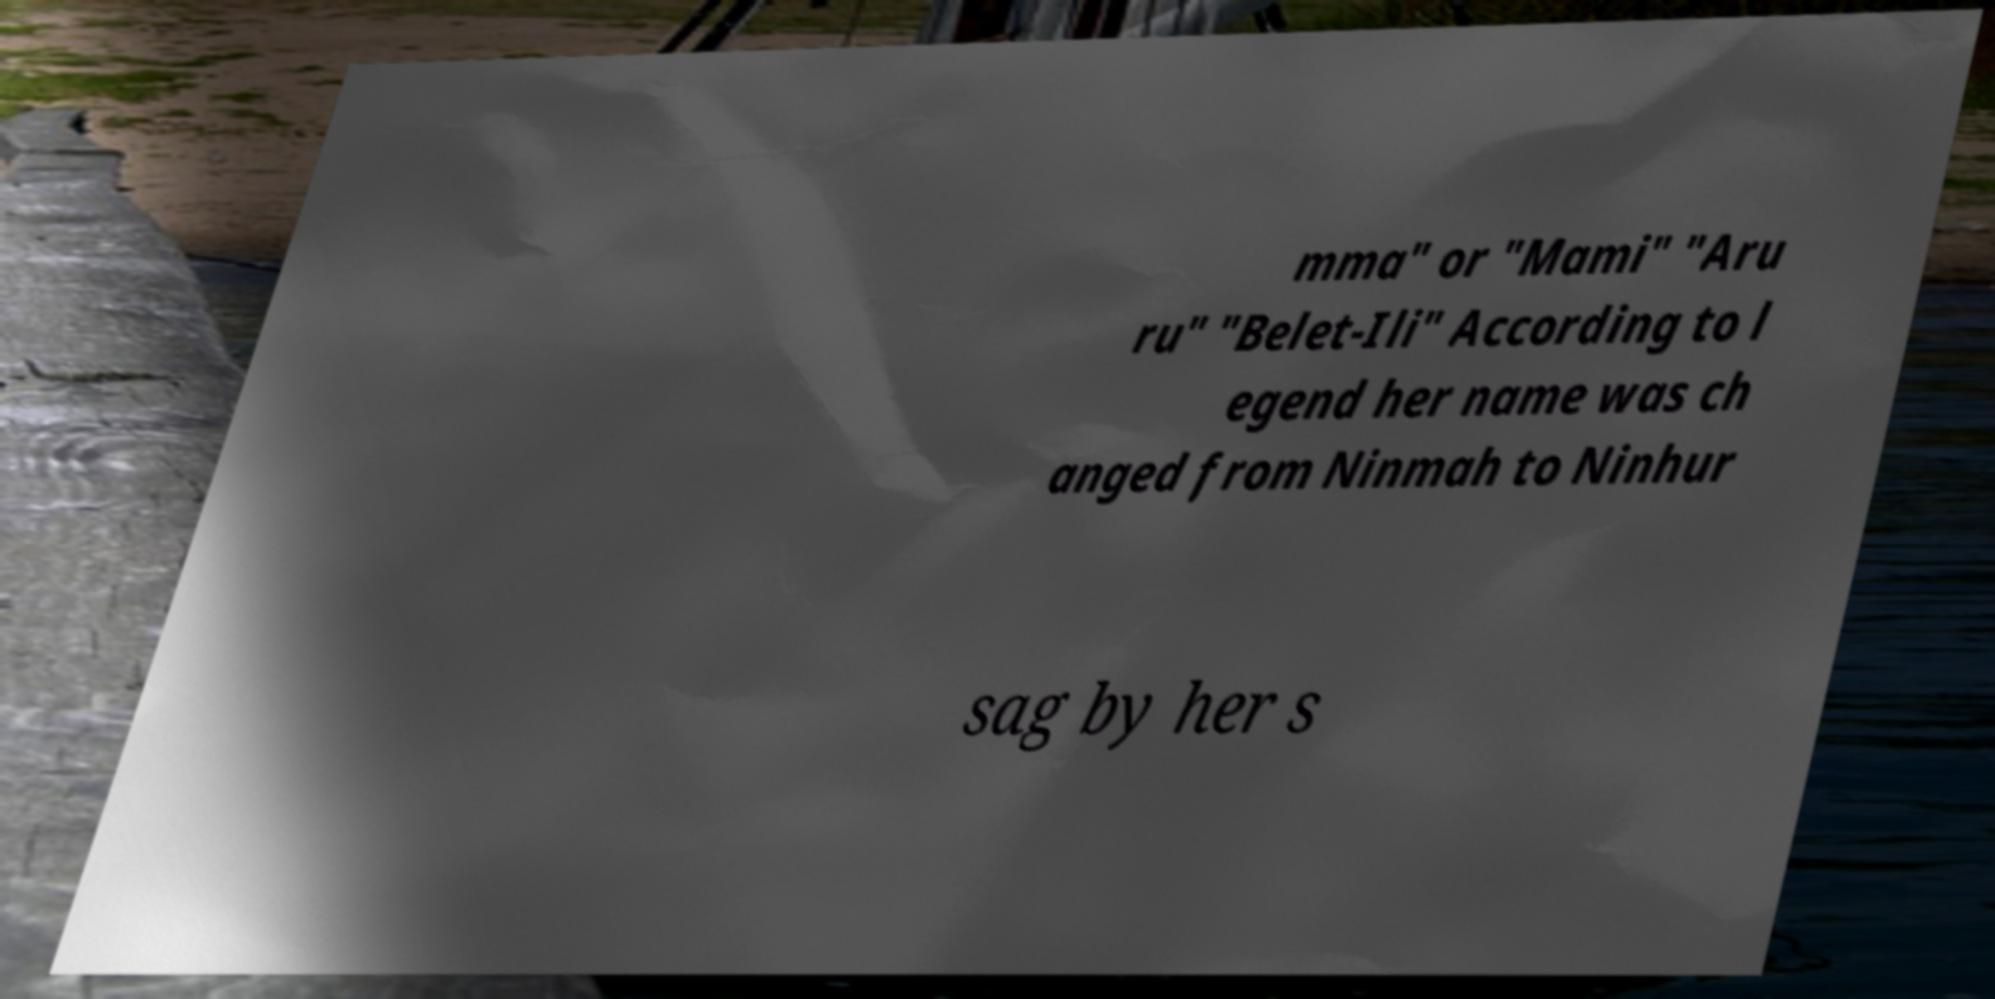Please identify and transcribe the text found in this image. mma" or "Mami" "Aru ru" "Belet-Ili" According to l egend her name was ch anged from Ninmah to Ninhur sag by her s 